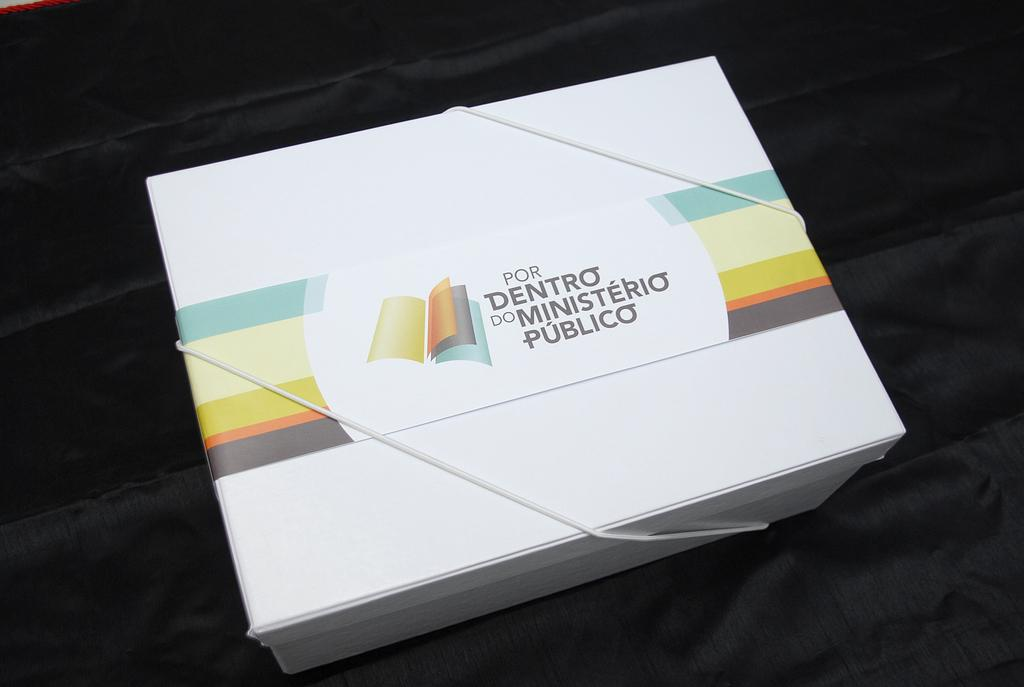<image>
Offer a succinct explanation of the picture presented. A box is imprinted with the phrase "por dentro do ministerio publico." 